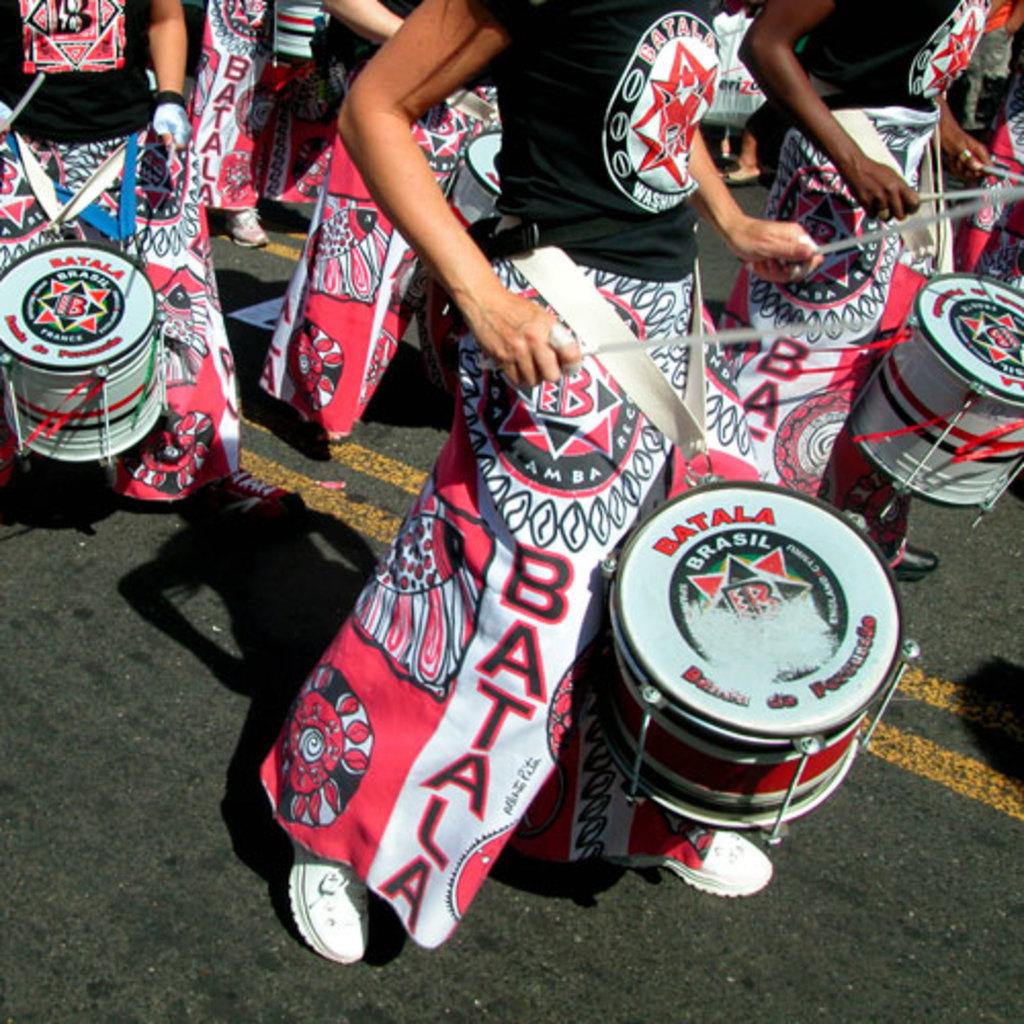What is this music project called?
Make the answer very short. Batala. 